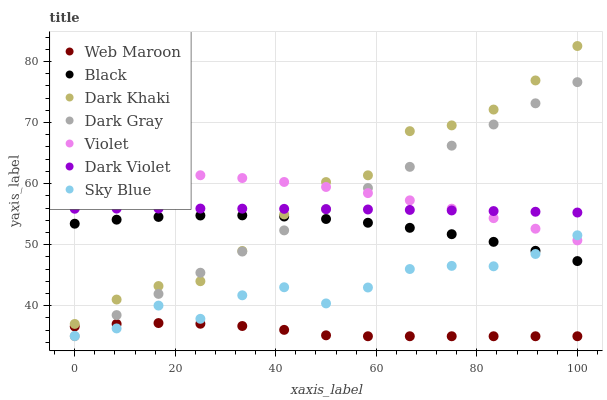Does Web Maroon have the minimum area under the curve?
Answer yes or no. Yes. Does Dark Khaki have the maximum area under the curve?
Answer yes or no. Yes. Does Dark Violet have the minimum area under the curve?
Answer yes or no. No. Does Dark Violet have the maximum area under the curve?
Answer yes or no. No. Is Dark Gray the smoothest?
Answer yes or no. Yes. Is Sky Blue the roughest?
Answer yes or no. Yes. Is Web Maroon the smoothest?
Answer yes or no. No. Is Web Maroon the roughest?
Answer yes or no. No. Does Dark Gray have the lowest value?
Answer yes or no. Yes. Does Dark Violet have the lowest value?
Answer yes or no. No. Does Dark Khaki have the highest value?
Answer yes or no. Yes. Does Dark Violet have the highest value?
Answer yes or no. No. Is Web Maroon less than Black?
Answer yes or no. Yes. Is Dark Violet greater than Black?
Answer yes or no. Yes. Does Sky Blue intersect Web Maroon?
Answer yes or no. Yes. Is Sky Blue less than Web Maroon?
Answer yes or no. No. Is Sky Blue greater than Web Maroon?
Answer yes or no. No. Does Web Maroon intersect Black?
Answer yes or no. No. 